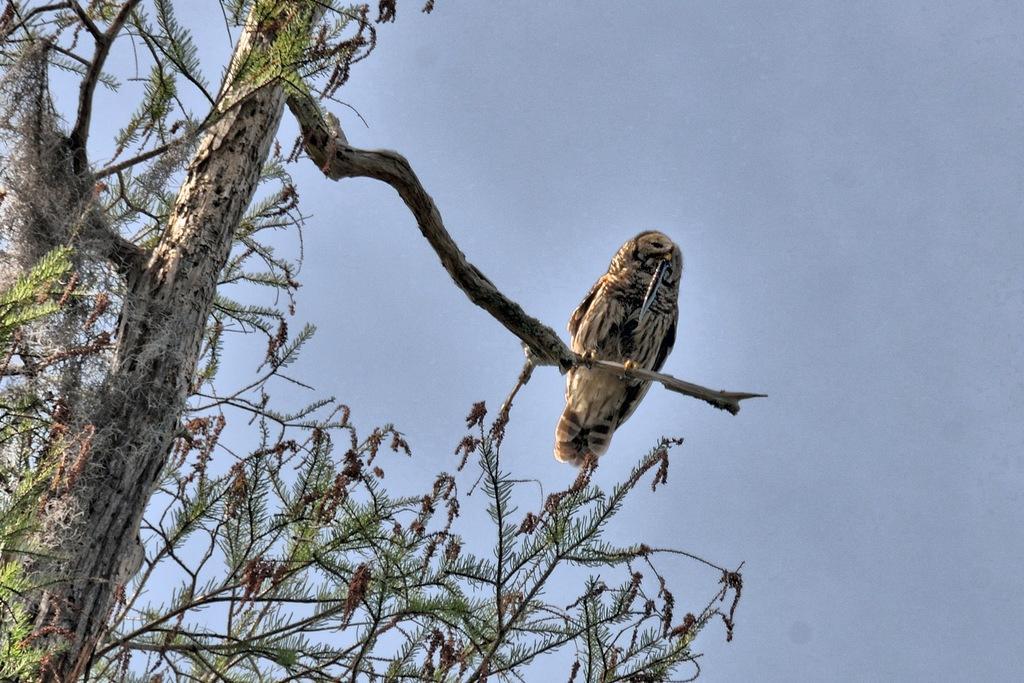Please provide a concise description of this image. In this image there is an owl on the tree stem. On the left side there is a tree with the green leaves. At the top there is the sky. 